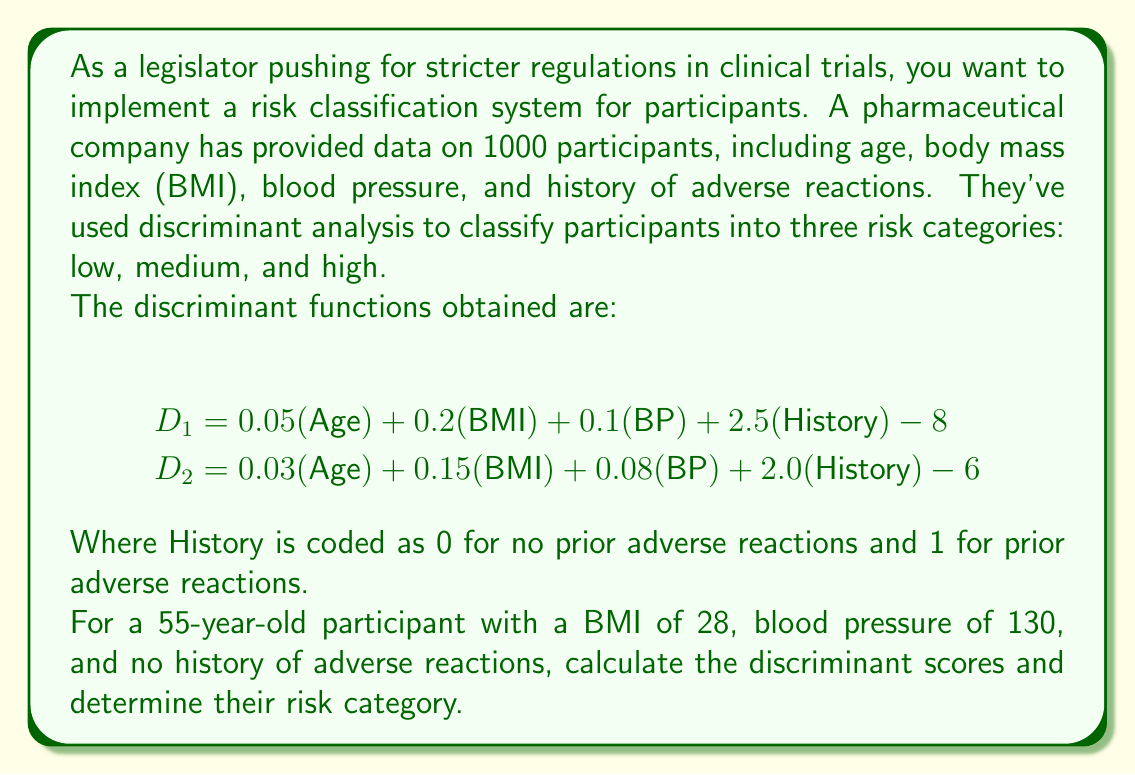Give your solution to this math problem. To solve this problem, we need to follow these steps:

1. Calculate the discriminant scores $D_1$ and $D_2$ using the given functions and participant data.
2. Compare the scores to determine the risk category.

Step 1: Calculating discriminant scores

Let's substitute the values into the discriminant functions:

For $D_1$:
$$\begin{align}
D_1 &= 0.05(\text{Age}) + 0.2(\text{BMI}) + 0.1(\text{BP}) + 2.5(\text{History}) - 8 \\
&= 0.05(55) + 0.2(28) + 0.1(130) + 2.5(0) - 8 \\
&= 2.75 + 5.6 + 13 - 8 \\
&= 13.35
\end{align}$$

For $D_2$:
$$\begin{align}
D_2 &= 0.03(\text{Age}) + 0.15(\text{BMI}) + 0.08(\text{BP}) + 2.0(\text{History}) - 6 \\
&= 0.03(55) + 0.15(28) + 0.08(130) + 2.0(0) - 6 \\
&= 1.65 + 4.2 + 10.4 - 6 \\
&= 10.25
\end{align}$$

Step 2: Determining the risk category

In discriminant analysis, the category with the highest discriminant score is typically chosen. Here, $D_1 > D_2$, so we would classify this participant into the category associated with $D_1$.

Assuming $D_1$ represents the boundary between low and medium risk, and $D_2$ represents the boundary between medium and high risk:

- If both $D_1$ and $D_2$ are negative, the participant is low risk.
- If $D_1$ is positive and $D_2$ is negative, the participant is medium risk.
- If both $D_1$ and $D_2$ are positive, the participant is high risk.

In this case, both $D_1$ (13.35) and $D_2$ (10.25) are positive, so the participant would be classified as high risk.
Answer: The participant's discriminant scores are $D_1 = 13.35$ and $D_2 = 10.25$. Based on these scores, the participant is classified as high risk. 